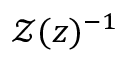Convert formula to latex. <formula><loc_0><loc_0><loc_500><loc_500>\mathcal { Z } ( z ) ^ { - 1 }</formula> 